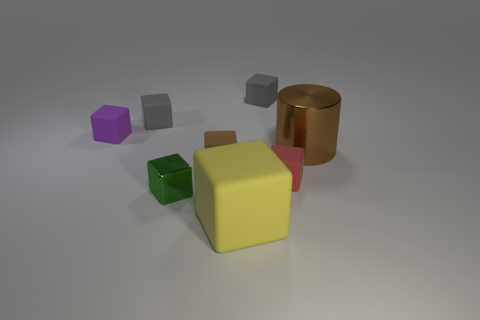How many gray blocks must be subtracted to get 1 gray blocks? 1 Subtract all small red blocks. How many blocks are left? 6 Add 1 large purple rubber objects. How many objects exist? 9 Subtract all gray cubes. How many cubes are left? 5 Subtract all cyan cylinders. Subtract all red spheres. How many cylinders are left? 1 Subtract all green cylinders. How many red blocks are left? 1 Subtract all purple blocks. Subtract all large matte things. How many objects are left? 6 Add 2 gray matte things. How many gray matte things are left? 4 Add 2 large cubes. How many large cubes exist? 3 Subtract 0 green cylinders. How many objects are left? 8 